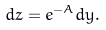<formula> <loc_0><loc_0><loc_500><loc_500>d z = e ^ { - A } d y .</formula> 